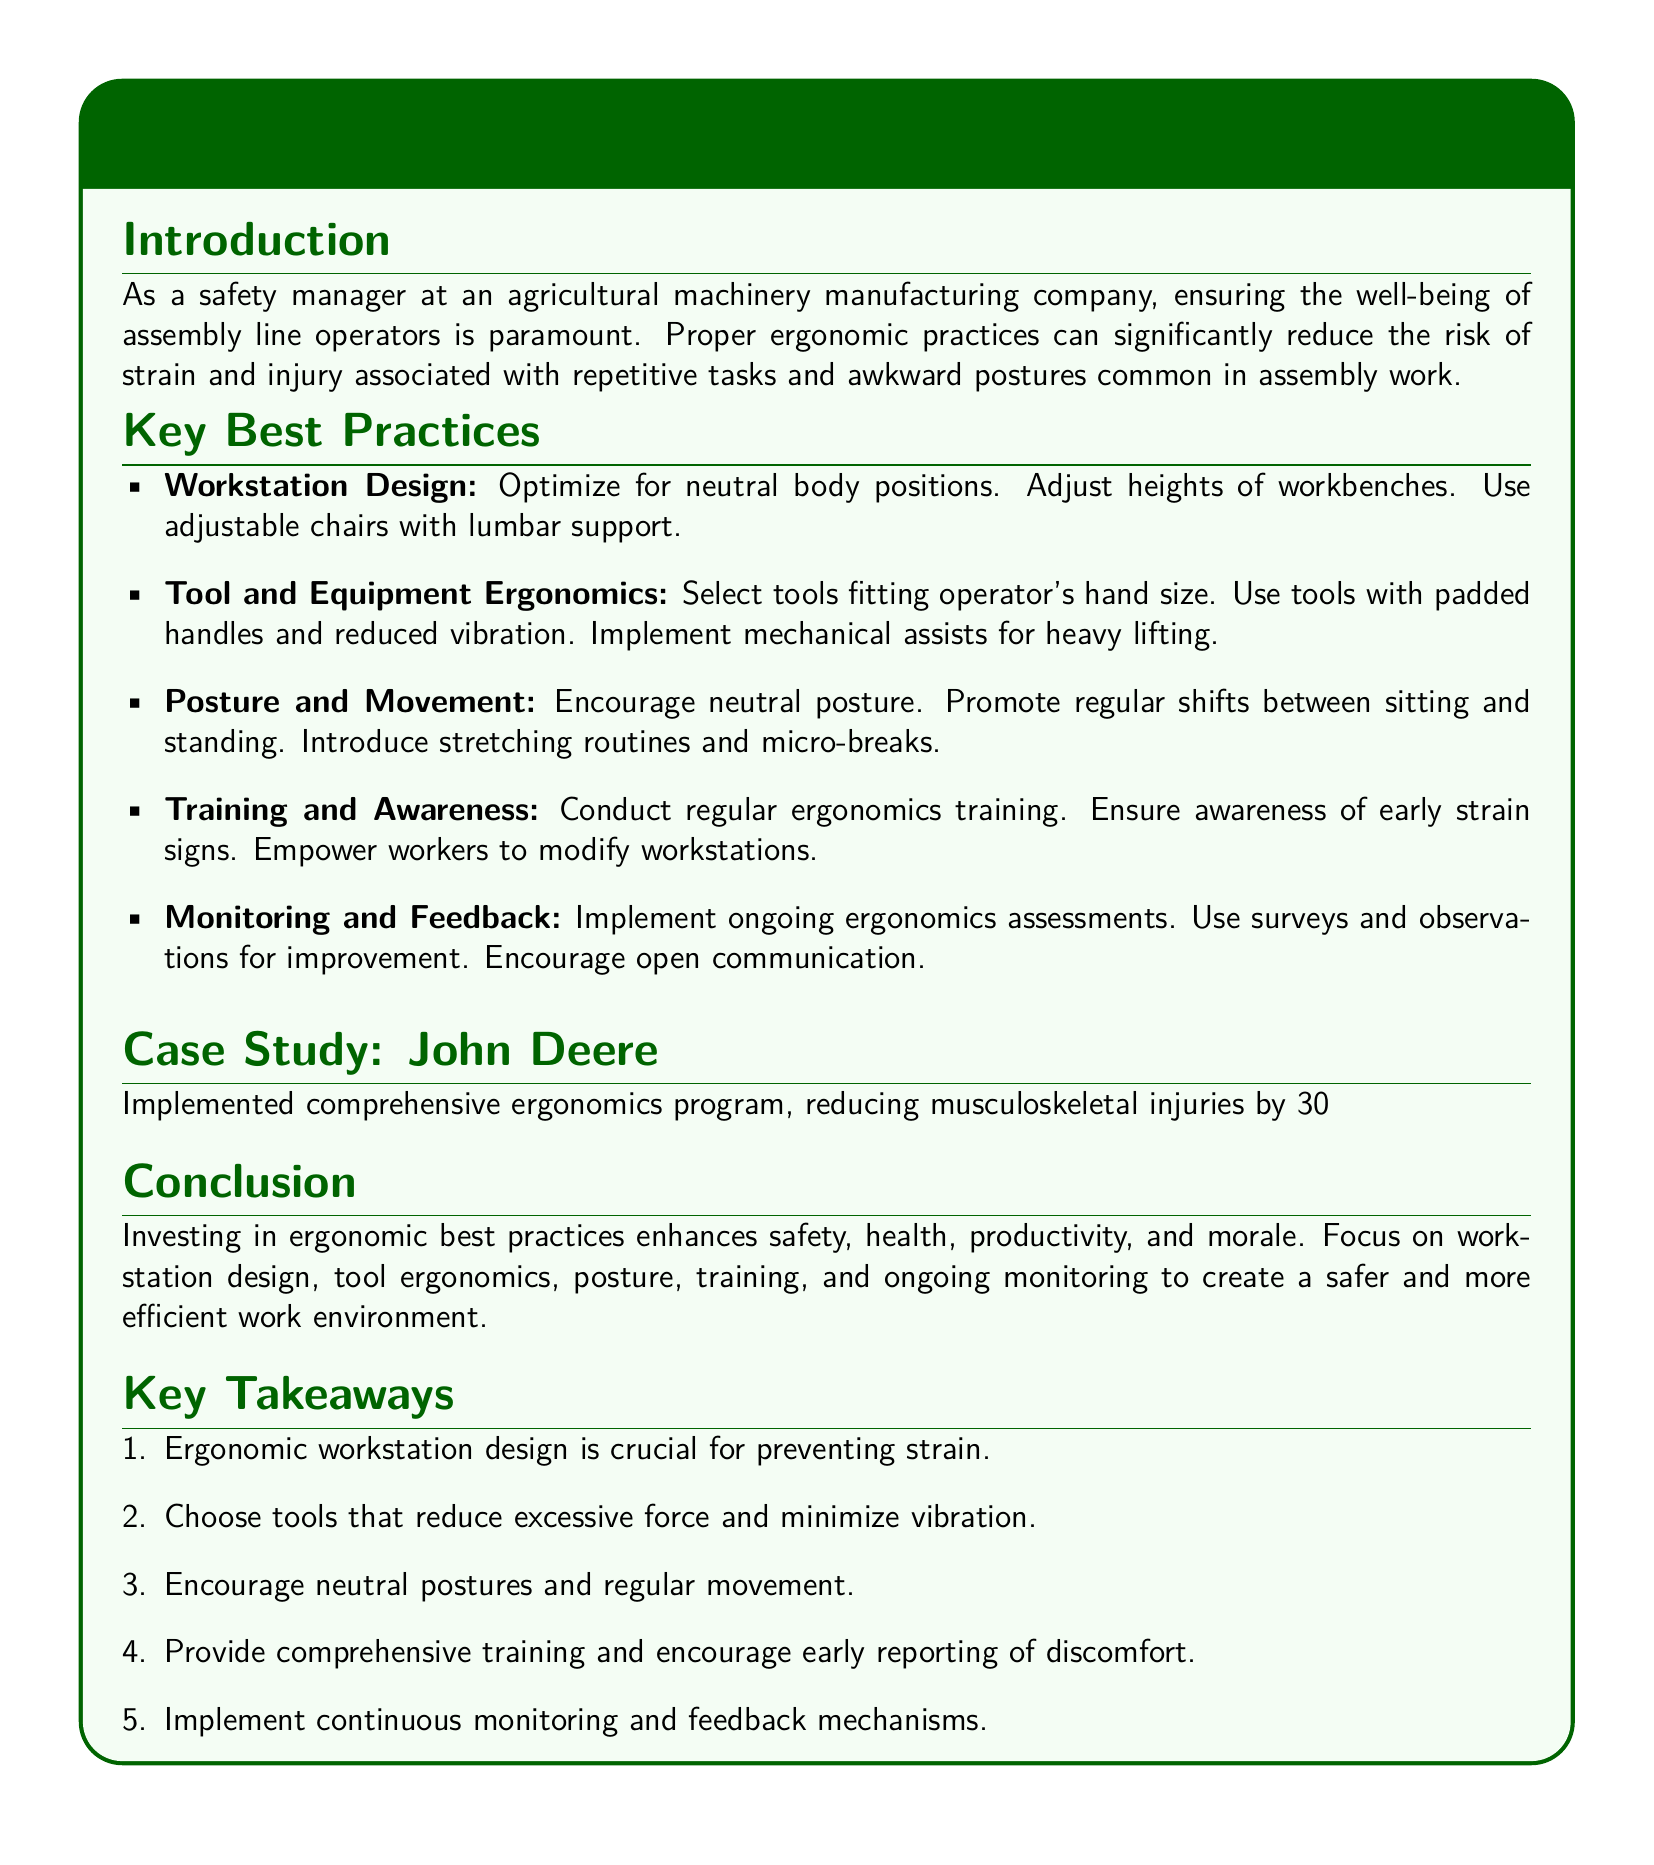What is the title of the document? The title is explicitly stated in the document's header.
Answer: Handling Ergonomics: Best Practices to Prevent Strain and Injury in Assembly Line Operators What percentage reduction in musculoskeletal injuries did John Deere achieve? The case study mentions the specific percentage reduction achieved by John Deere.
Answer: 30% What is the first best practice listed in the document? The best practices are organized in a list, with the first item indicating the focus area.
Answer: Workstation Design What is a suggested tool feature for ergonomics? The document explicitly lists desirable features of tools to enhance ergonomics.
Answer: Padded handles What action should be encouraged to reduce strain according to the document? The conclusion summarizes important actions designed to enhance safety and health.
Answer: Neutral postures What is the role of training in ergonomics according to the document? The document emphasizes the importance of training in the context of ergonomics.
Answer: Conduct regular ergonomics training What kind of assessments should be implemented for ergonomics? The document highlights the need for certain assessments to maintain ergonomics standards.
Answer: Ongoing ergonomics assessments What is one benefit of investing in ergonomic practices? The document concludes with a summary of benefits concerning ergonomic practices.
Answer: Enhanced safety 